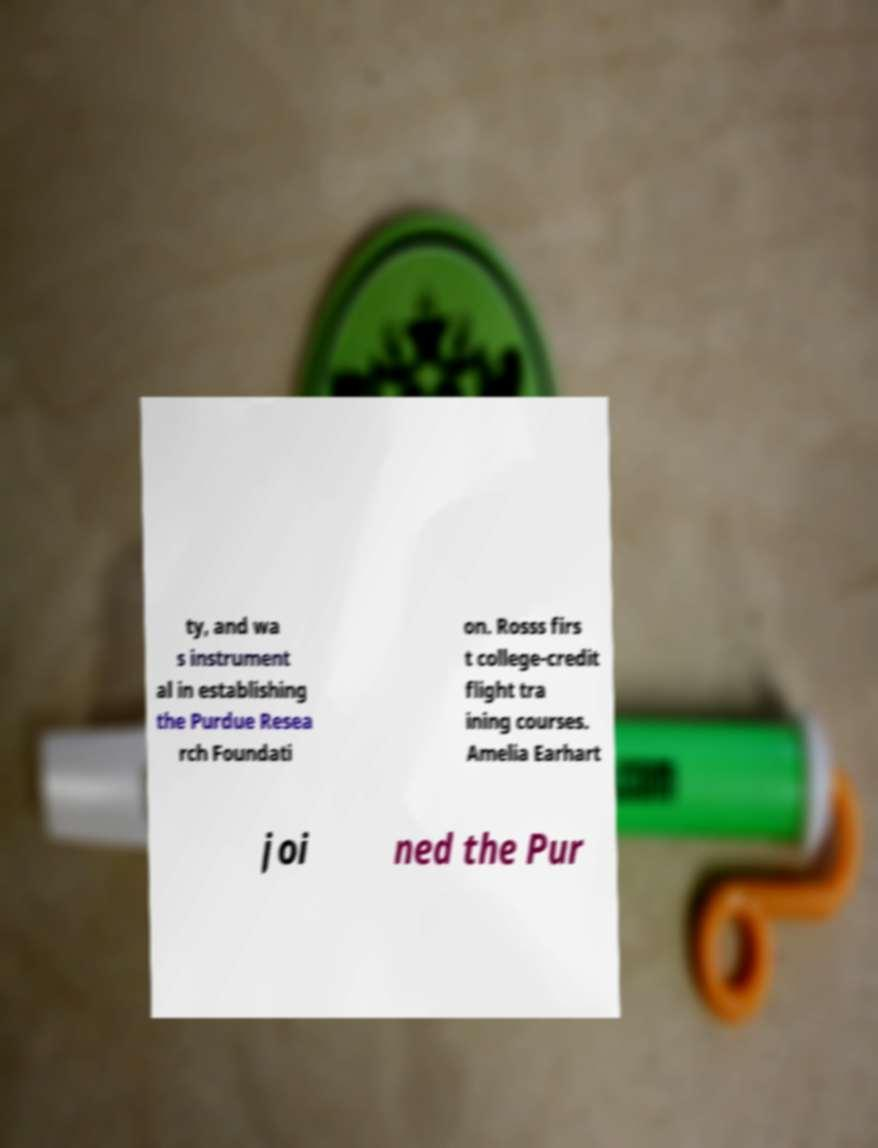Can you accurately transcribe the text from the provided image for me? ty, and wa s instrument al in establishing the Purdue Resea rch Foundati on. Rosss firs t college-credit flight tra ining courses. Amelia Earhart joi ned the Pur 